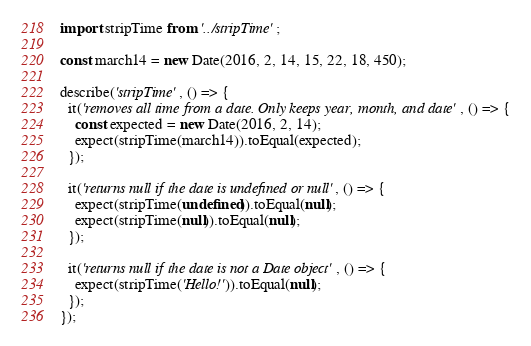Convert code to text. <code><loc_0><loc_0><loc_500><loc_500><_JavaScript_>
import stripTime from '../stripTime';

const march14 = new Date(2016, 2, 14, 15, 22, 18, 450);

describe('stripTime', () => {
  it('removes all time from a date. Only keeps year, month, and date', () => {
    const expected = new Date(2016, 2, 14);
    expect(stripTime(march14)).toEqual(expected);
  });

  it('returns null if the date is undefined or null', () => {
    expect(stripTime(undefined)).toEqual(null);
    expect(stripTime(null)).toEqual(null);
  });

  it('returns null if the date is not a Date object', () => {
    expect(stripTime('Hello!')).toEqual(null);
  });
});
</code> 